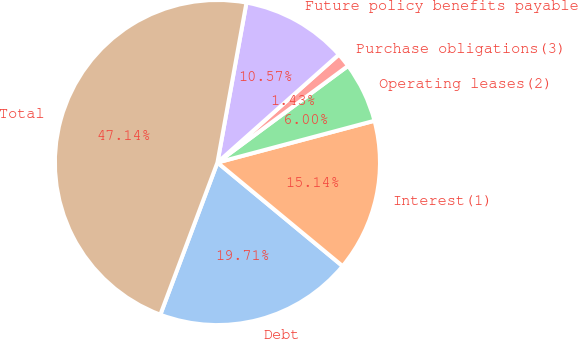Convert chart to OTSL. <chart><loc_0><loc_0><loc_500><loc_500><pie_chart><fcel>Debt<fcel>Interest(1)<fcel>Operating leases(2)<fcel>Purchase obligations(3)<fcel>Future policy benefits payable<fcel>Total<nl><fcel>19.71%<fcel>15.14%<fcel>6.0%<fcel>1.43%<fcel>10.57%<fcel>47.14%<nl></chart> 